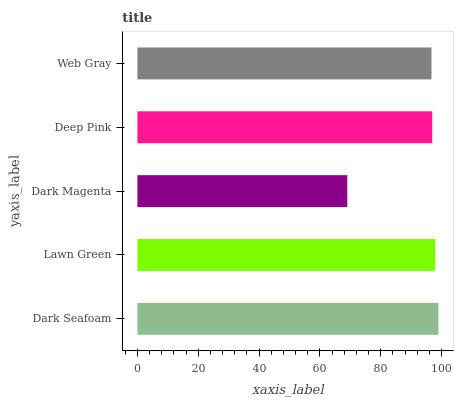Is Dark Magenta the minimum?
Answer yes or no. Yes. Is Dark Seafoam the maximum?
Answer yes or no. Yes. Is Lawn Green the minimum?
Answer yes or no. No. Is Lawn Green the maximum?
Answer yes or no. No. Is Dark Seafoam greater than Lawn Green?
Answer yes or no. Yes. Is Lawn Green less than Dark Seafoam?
Answer yes or no. Yes. Is Lawn Green greater than Dark Seafoam?
Answer yes or no. No. Is Dark Seafoam less than Lawn Green?
Answer yes or no. No. Is Deep Pink the high median?
Answer yes or no. Yes. Is Deep Pink the low median?
Answer yes or no. Yes. Is Dark Seafoam the high median?
Answer yes or no. No. Is Dark Seafoam the low median?
Answer yes or no. No. 